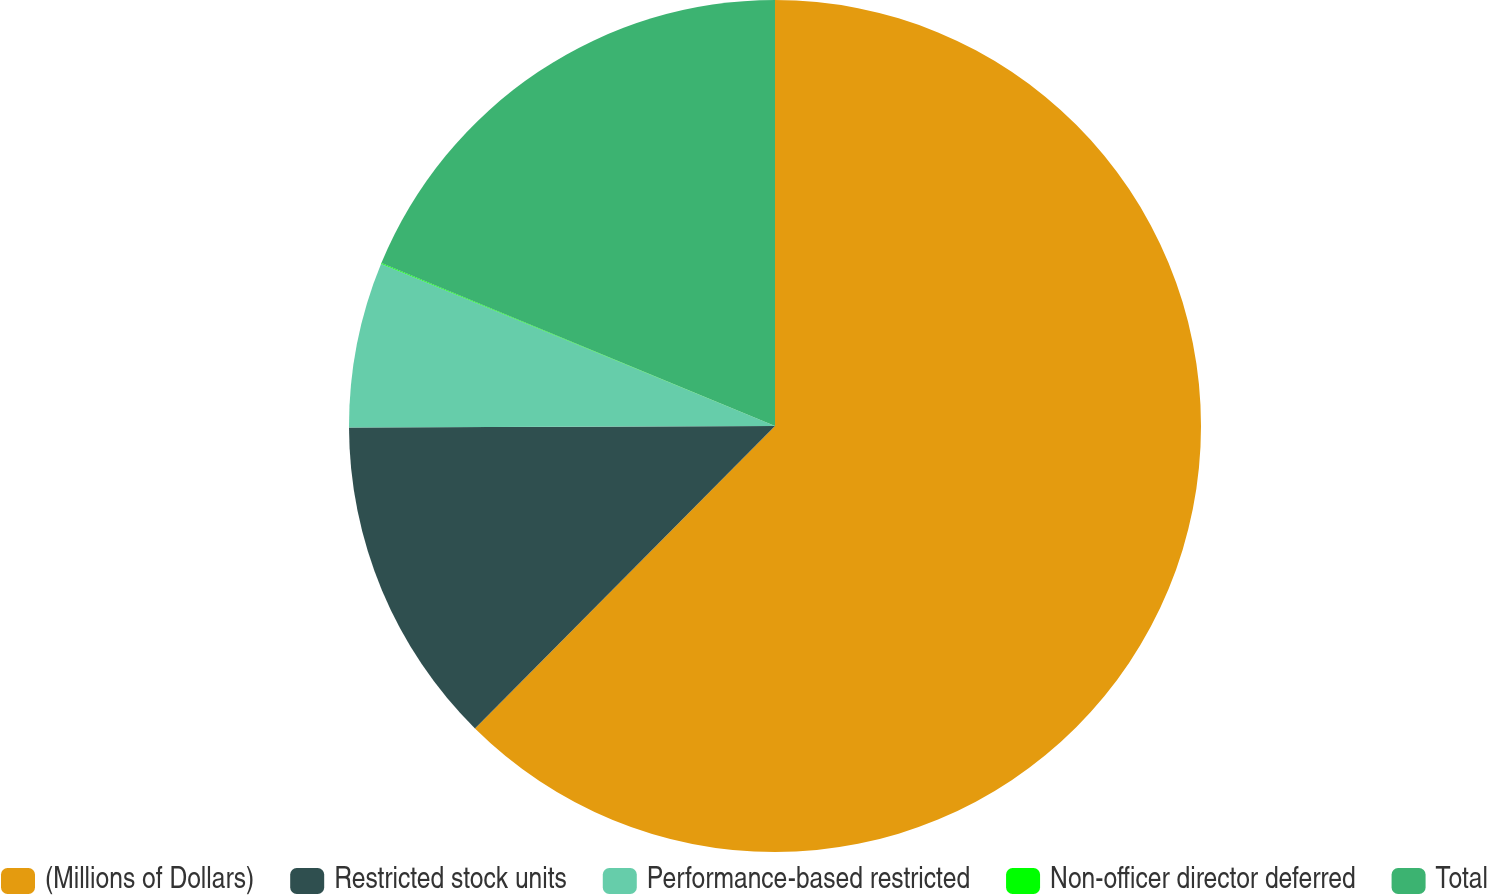Convert chart. <chart><loc_0><loc_0><loc_500><loc_500><pie_chart><fcel>(Millions of Dollars)<fcel>Restricted stock units<fcel>Performance-based restricted<fcel>Non-officer director deferred<fcel>Total<nl><fcel>62.43%<fcel>12.51%<fcel>6.27%<fcel>0.03%<fcel>18.75%<nl></chart> 